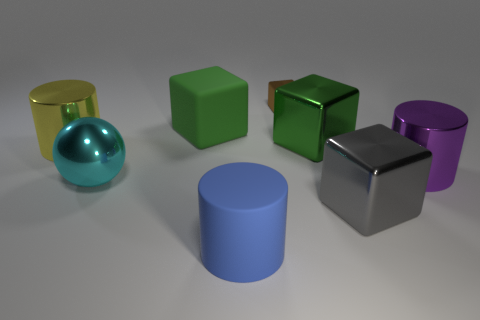Are there any purple shiny things that have the same size as the matte cylinder?
Your answer should be very brief. Yes. Is the number of big green matte cubes left of the blue rubber thing greater than the number of big green shiny blocks in front of the purple cylinder?
Your answer should be compact. Yes. Is the material of the big green object that is right of the tiny brown block the same as the large blue object that is on the right side of the big yellow metallic cylinder?
Your response must be concise. No. There is a cyan shiny thing that is the same size as the gray shiny thing; what shape is it?
Provide a succinct answer. Sphere. Is there a green shiny thing that has the same shape as the small brown thing?
Your response must be concise. Yes. Is the color of the cube that is left of the blue cylinder the same as the block that is in front of the purple shiny thing?
Ensure brevity in your answer.  No. There is a gray metal block; are there any big cubes behind it?
Make the answer very short. Yes. What is the material of the big thing that is both to the left of the big green metallic block and on the right side of the large green rubber object?
Your answer should be compact. Rubber. Is the large green block on the left side of the brown shiny block made of the same material as the large blue cylinder?
Give a very brief answer. Yes. What material is the large gray thing?
Keep it short and to the point. Metal. 